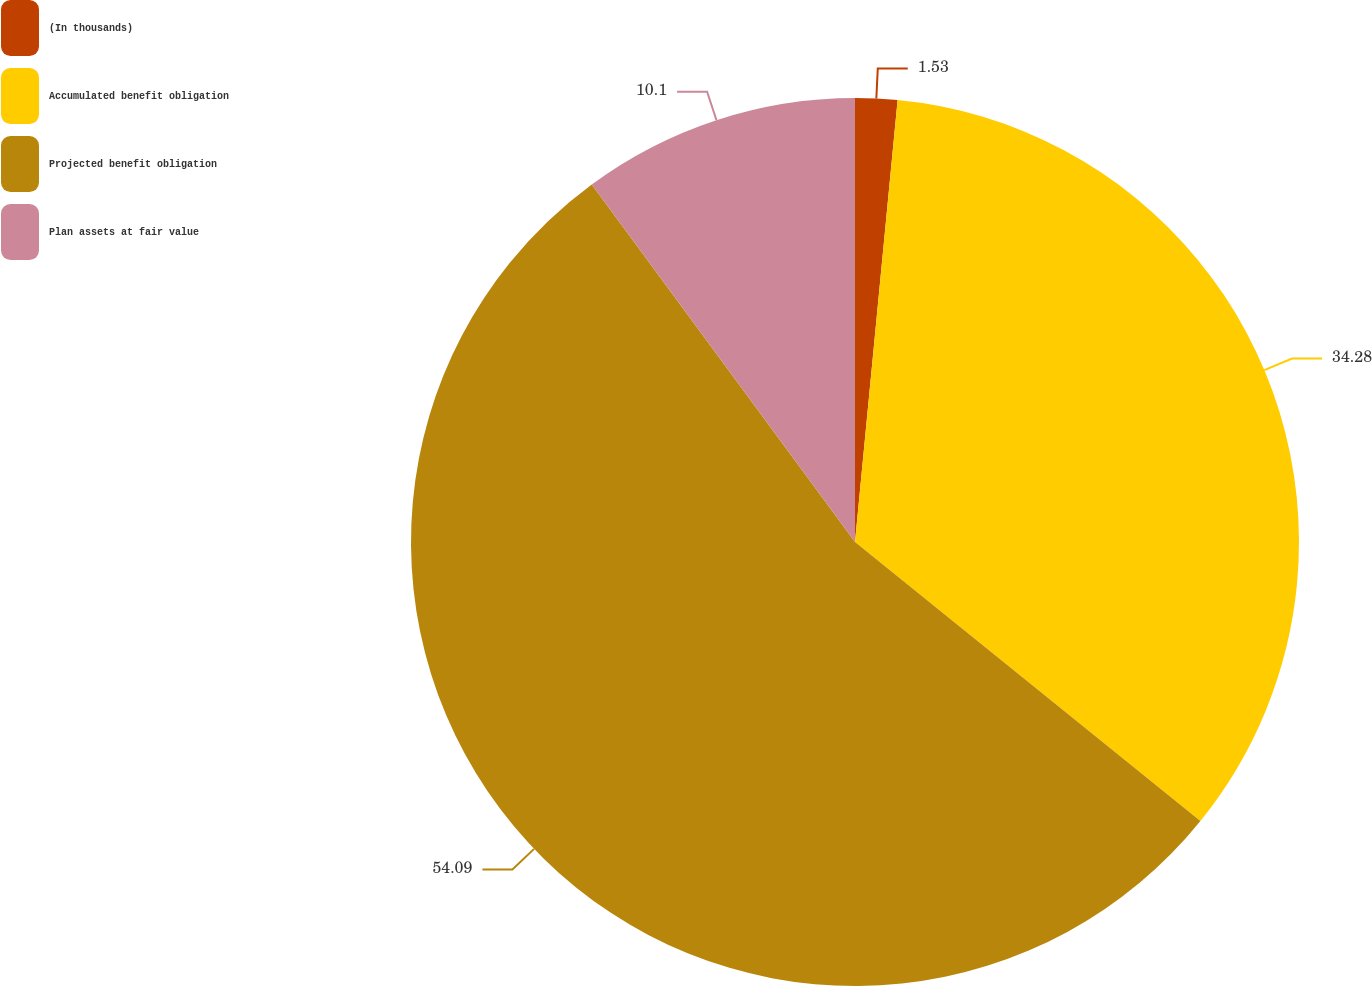<chart> <loc_0><loc_0><loc_500><loc_500><pie_chart><fcel>(In thousands)<fcel>Accumulated benefit obligation<fcel>Projected benefit obligation<fcel>Plan assets at fair value<nl><fcel>1.53%<fcel>34.28%<fcel>54.08%<fcel>10.1%<nl></chart> 